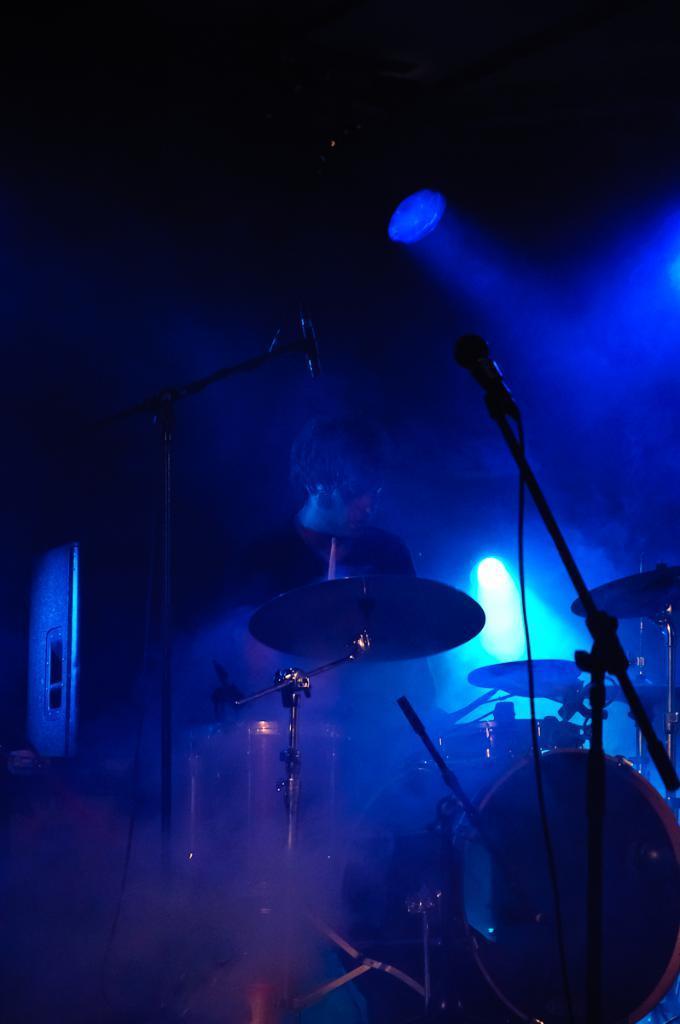Describe this image in one or two sentences. In this image I can see a person standing. In front I can see few musical instruments,mic and stand. I can see a dark background and blue lights. 